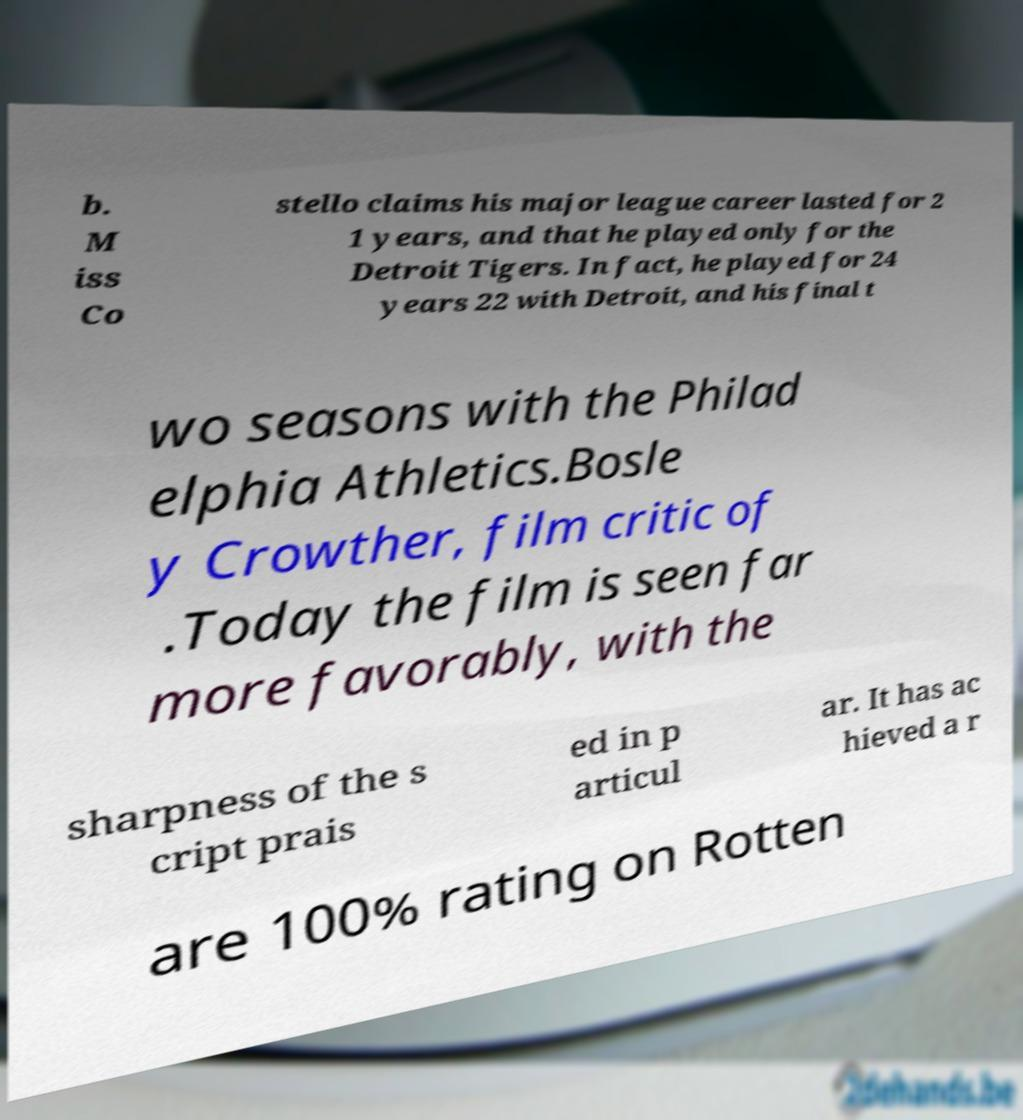Could you extract and type out the text from this image? b. M iss Co stello claims his major league career lasted for 2 1 years, and that he played only for the Detroit Tigers. In fact, he played for 24 years 22 with Detroit, and his final t wo seasons with the Philad elphia Athletics.Bosle y Crowther, film critic of .Today the film is seen far more favorably, with the sharpness of the s cript prais ed in p articul ar. It has ac hieved a r are 100% rating on Rotten 